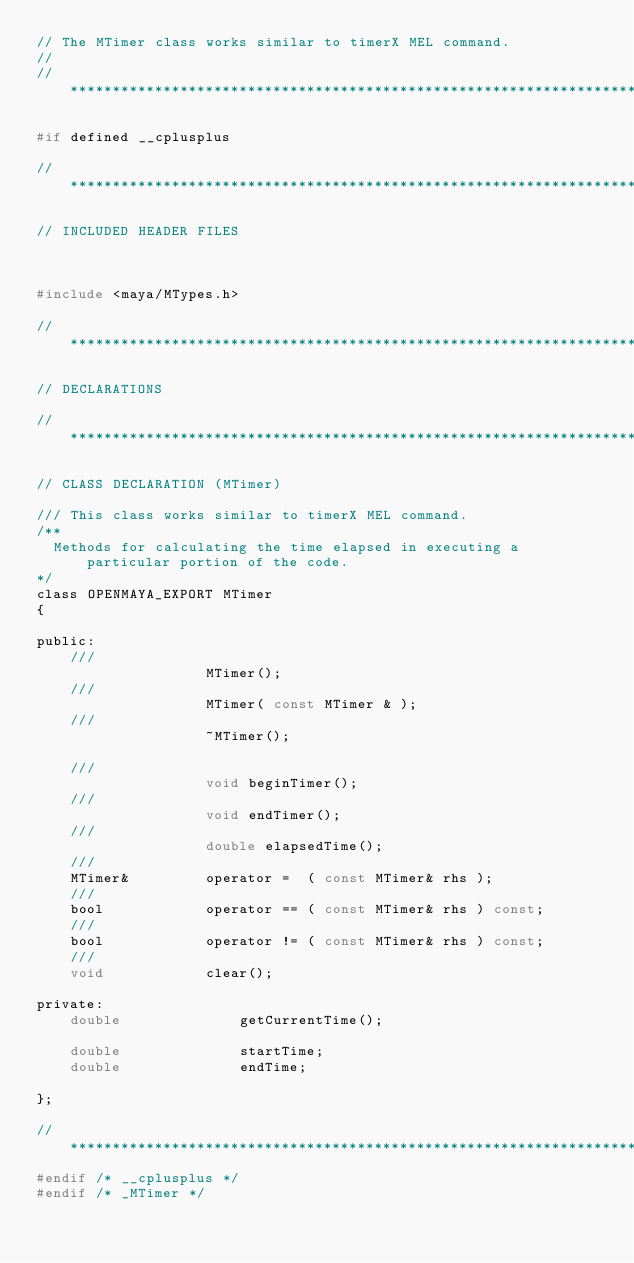<code> <loc_0><loc_0><loc_500><loc_500><_C_>// The MTimer class works similar to timerX MEL command.
//
// *****************************************************************************

#if defined __cplusplus

// *****************************************************************************

// INCLUDED HEADER FILES



#include <maya/MTypes.h>

// *****************************************************************************

// DECLARATIONS

// *****************************************************************************

// CLASS DECLARATION (MTimer)

/// This class works similar to timerX MEL command.
/**
  Methods for calculating the time elapsed in executing a particular portion of the code.
*/
class OPENMAYA_EXPORT MTimer  
{

public:
	///
					MTimer();
	///
					MTimer( const MTimer & );
	///
					~MTimer();

	///
					void beginTimer();
	///
					void endTimer();
	///
					double elapsedTime();
	///
	MTimer&			operator =  ( const MTimer& rhs );
	///
	bool			operator == ( const MTimer& rhs ) const;
	///
	bool			operator != ( const MTimer& rhs ) const;
	///
	void			clear();

private:
	double				getCurrentTime();

	double				startTime;
	double				endTime;

};

// *****************************************************************************
#endif /* __cplusplus */
#endif /* _MTimer */
</code> 